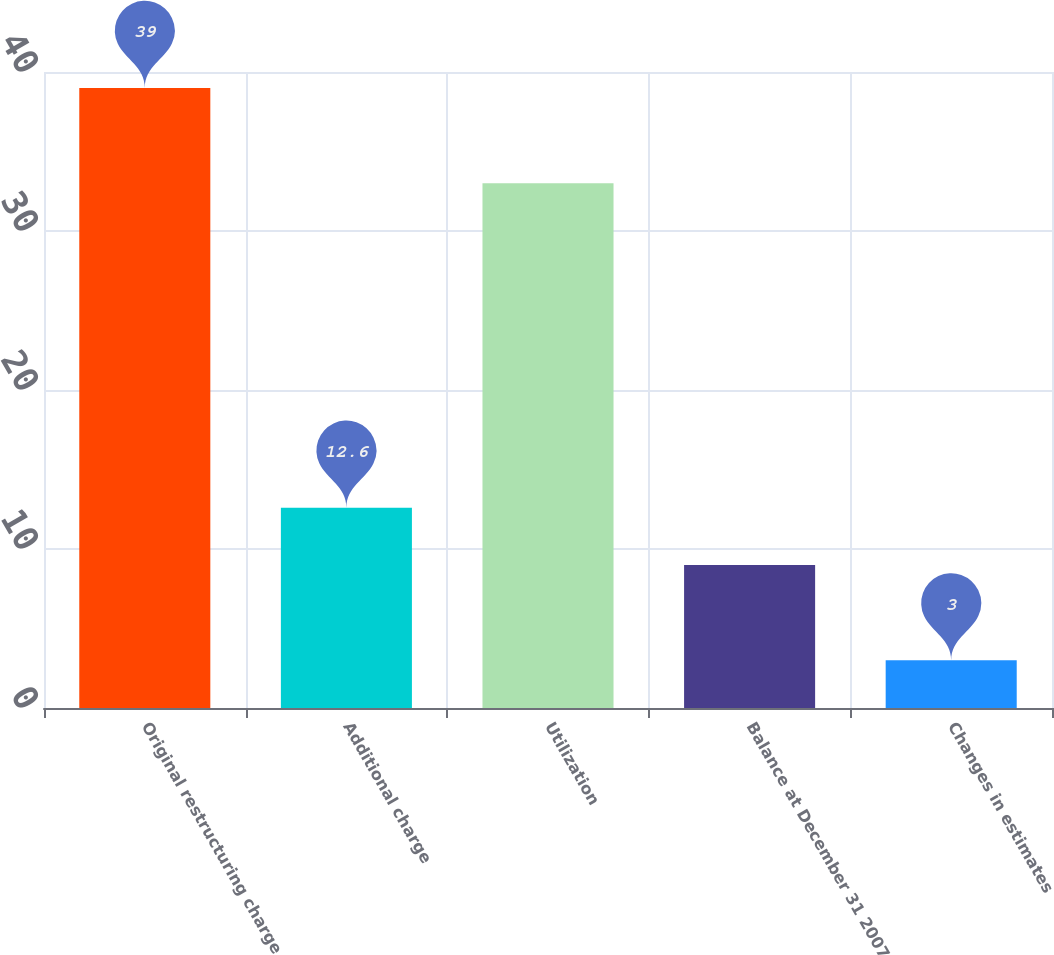Convert chart. <chart><loc_0><loc_0><loc_500><loc_500><bar_chart><fcel>Original restructuring charge<fcel>Additional charge<fcel>Utilization<fcel>Balance at December 31 2007<fcel>Changes in estimates<nl><fcel>39<fcel>12.6<fcel>33<fcel>9<fcel>3<nl></chart> 